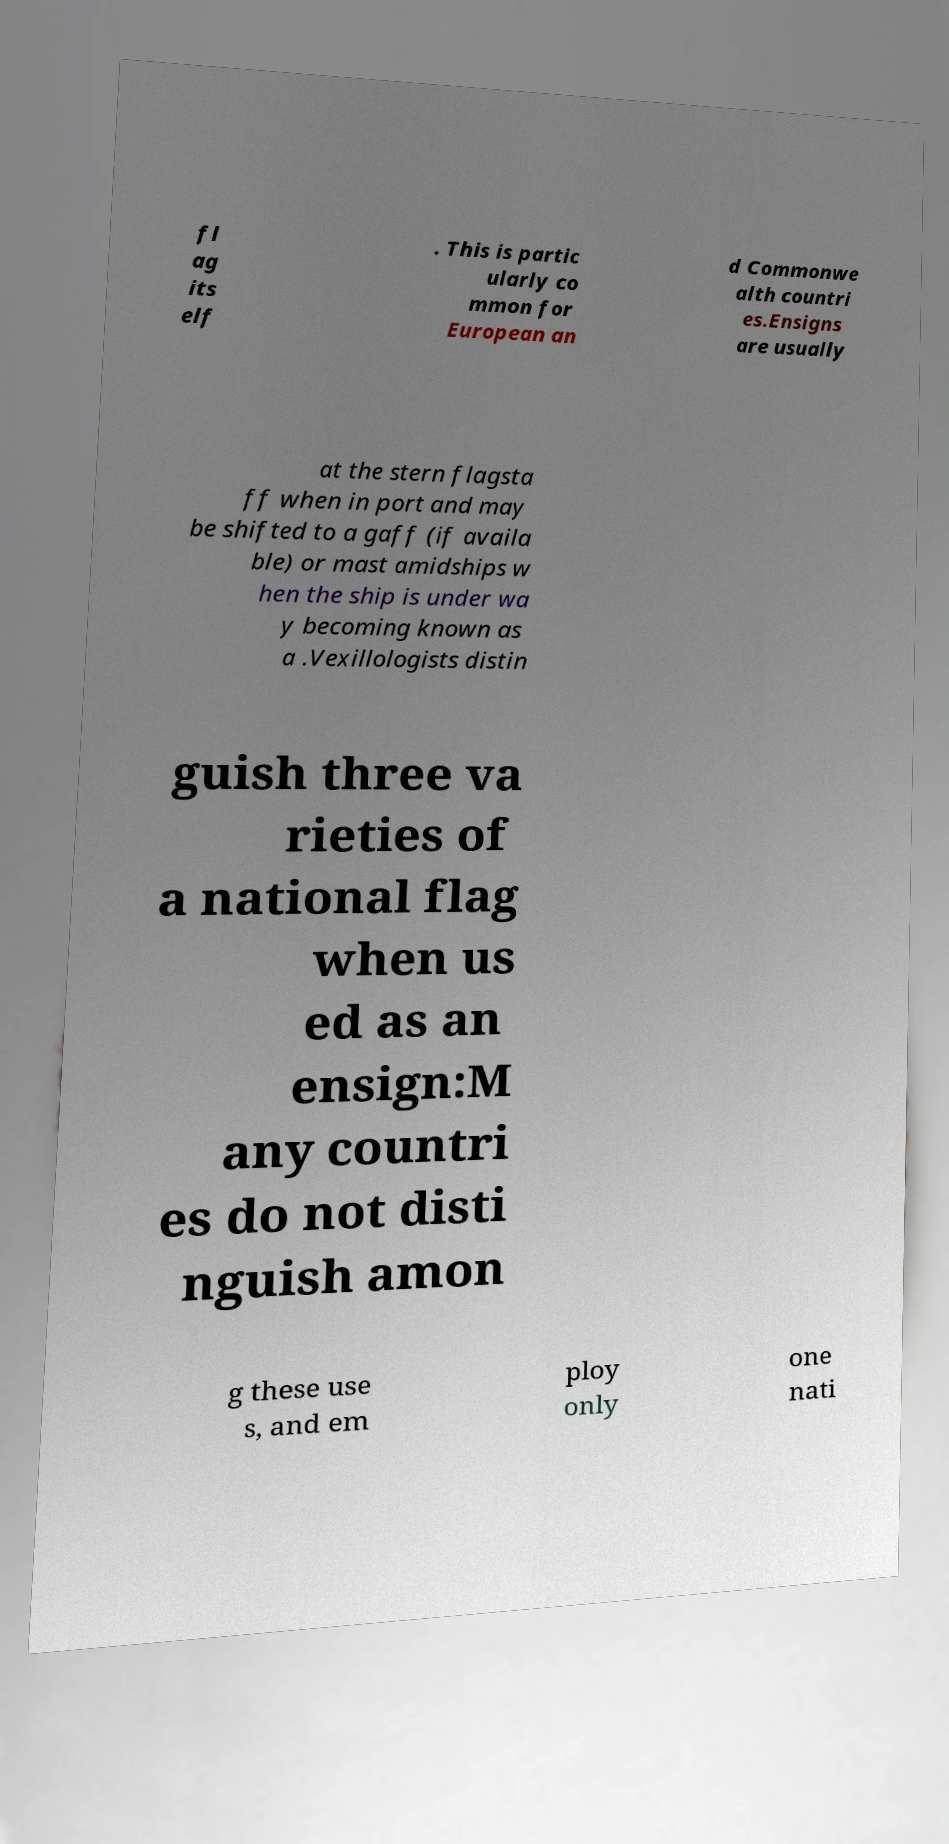Can you read and provide the text displayed in the image?This photo seems to have some interesting text. Can you extract and type it out for me? fl ag its elf . This is partic ularly co mmon for European an d Commonwe alth countri es.Ensigns are usually at the stern flagsta ff when in port and may be shifted to a gaff (if availa ble) or mast amidships w hen the ship is under wa y becoming known as a .Vexillologists distin guish three va rieties of a national flag when us ed as an ensign:M any countri es do not disti nguish amon g these use s, and em ploy only one nati 